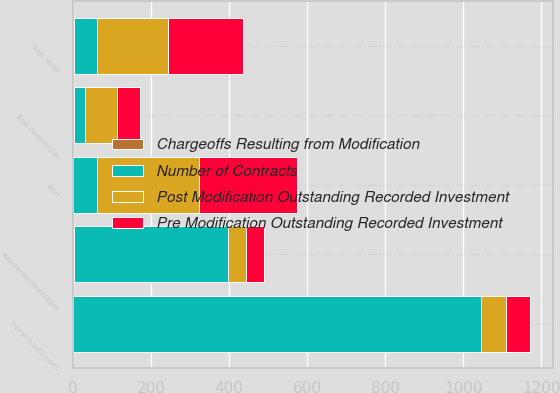Convert chart. <chart><loc_0><loc_0><loc_500><loc_500><stacked_bar_chart><ecel><fcel>Total commercial<fcel>Residential mortgages<fcel>Home equity loans<fcel>Total retail<fcel>Total<nl><fcel>Number of Contracts<fcel>28<fcel>393<fcel>1046<fcel>60.5<fcel>60.5<nl><fcel>Pre Modification Outstanding Recorded Investment<fcel>59<fcel>47<fcel>63<fcel>192<fcel>251<nl><fcel>Post Modification Outstanding Recorded Investment<fcel>81<fcel>46<fcel>62<fcel>181<fcel>262<nl><fcel>Chargeoffs Resulting from Modification<fcel>3<fcel>4<fcel>1<fcel>2<fcel>1<nl></chart> 